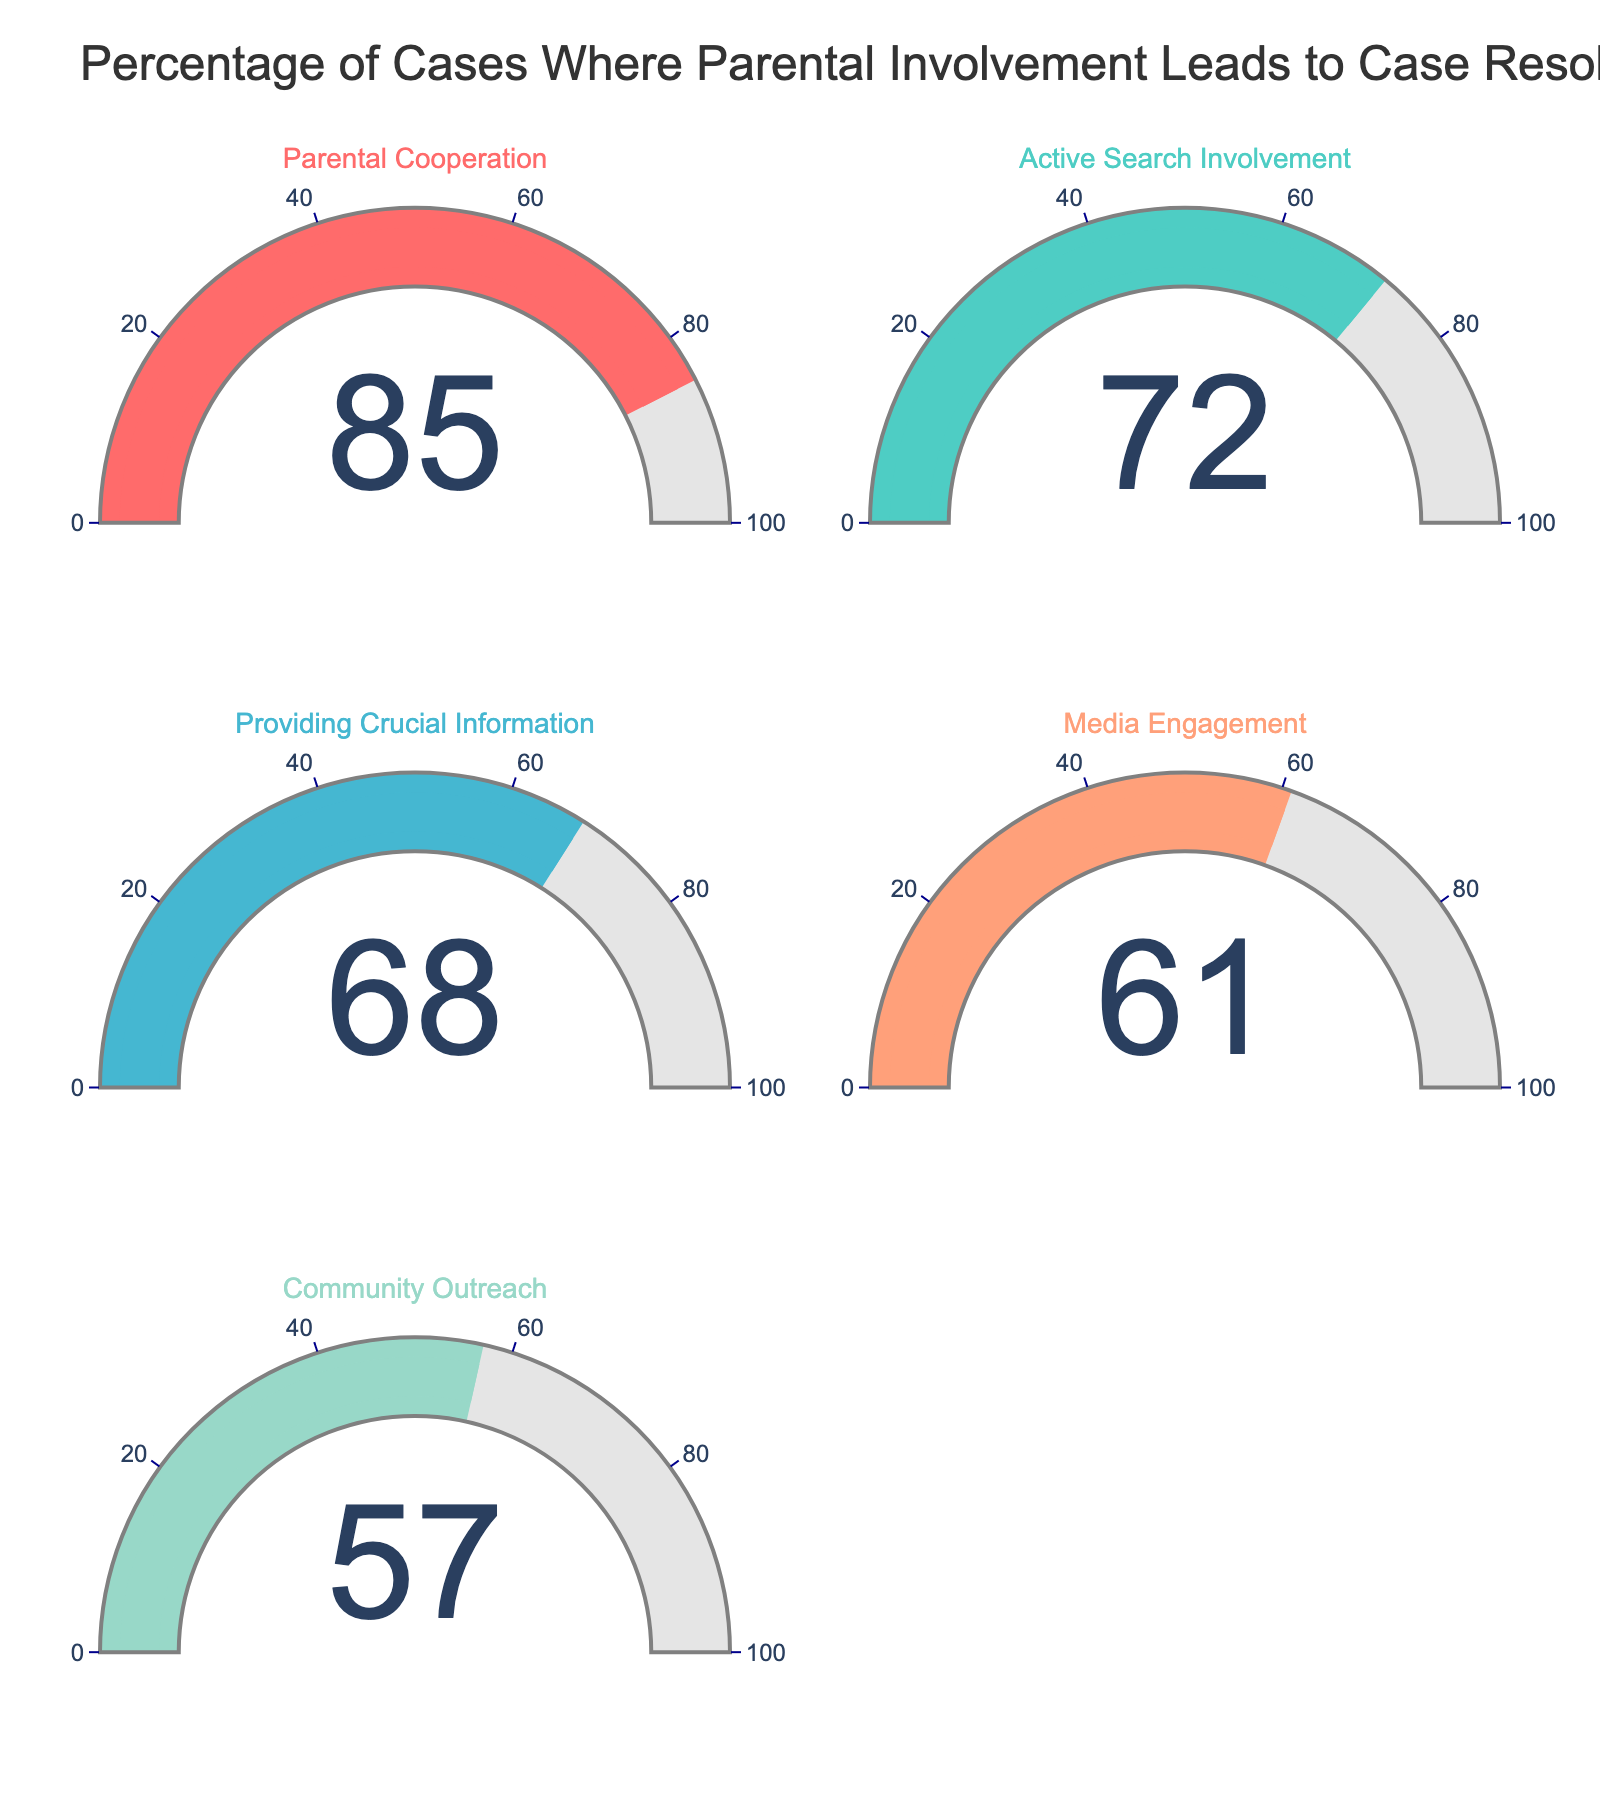What is the highest percentage shown on the gauges? The highest percentage is indicated on the gauge displaying "Parental Cooperation," which shows 85%.
Answer: 85% Which category has the lowest percentage of parental involvement leading to case resolution? By comparing all the gauges, the category "Community Outreach" shows the lowest percentage at 57%.
Answer: Community Outreach What is the combined percentage of "Active Search Involvement" and "Media Engagement"? The percentage for "Active Search Involvement" is 72% and for "Media Engagement" is 61%. Adding these together gives 72 + 61 = 133.
Answer: 133 Is the percentage for "Providing Crucial Information" greater than "Community Outreach"? The percentage for "Providing Crucial Information" is 68%, and for "Community Outreach" it is 57%. Since 68 is greater than 57, the statement is true.
Answer: Yes How much more significant is the percentage for "Parental Cooperation" compared to "Media Engagement"? The percentage for "Parental Cooperation" is 85%, and for "Media Engagement" it is 61%. The difference between these is 85 - 61 = 24.
Answer: 24 Which two categories have the closest percentages? By comparing the percentages, "Providing Crucial Information" (68%) and "Active Search Involvement" (72%) are the closest with a difference of 4%.
Answer: Providing Crucial Information and Active Search Involvement What is the average percentage across all the categories? Adding the percentages: 85 (Parental Cooperation) + 72 (Active Search Involvement) + 68 (Providing Crucial Information) + 61 (Media Engagement) + 57 (Community Outreach) = 343. The average is then 343 / 5 = 68.6.
Answer: 68.6 List the categories in descending order of their percentages. The categories and their percentages in descending order are: Parental Cooperation (85%), Active Search Involvement (72%), Providing Crucial Information (68%), Media Engagement (61%), Community Outreach (57%).
Answer: Parental Cooperation, Active Search Involvement, Providing Crucial Information, Media Engagement, Community Outreach 